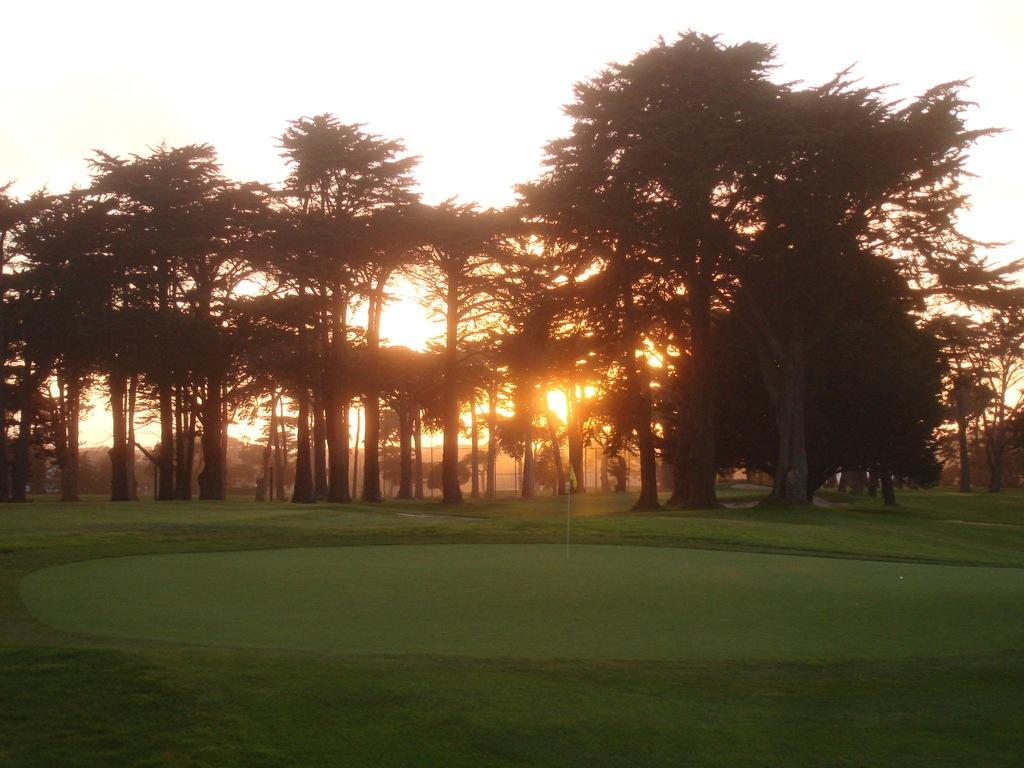What type of vegetation is present in the image? There are trees in the image. What else can be seen on the ground in the image? There is grass in the image. What is visible in the background of the image? The sky is visible in the background of the image. What type of prison can be seen in the image? There is no prison present in the image; it features trees, grass, and the sky. 